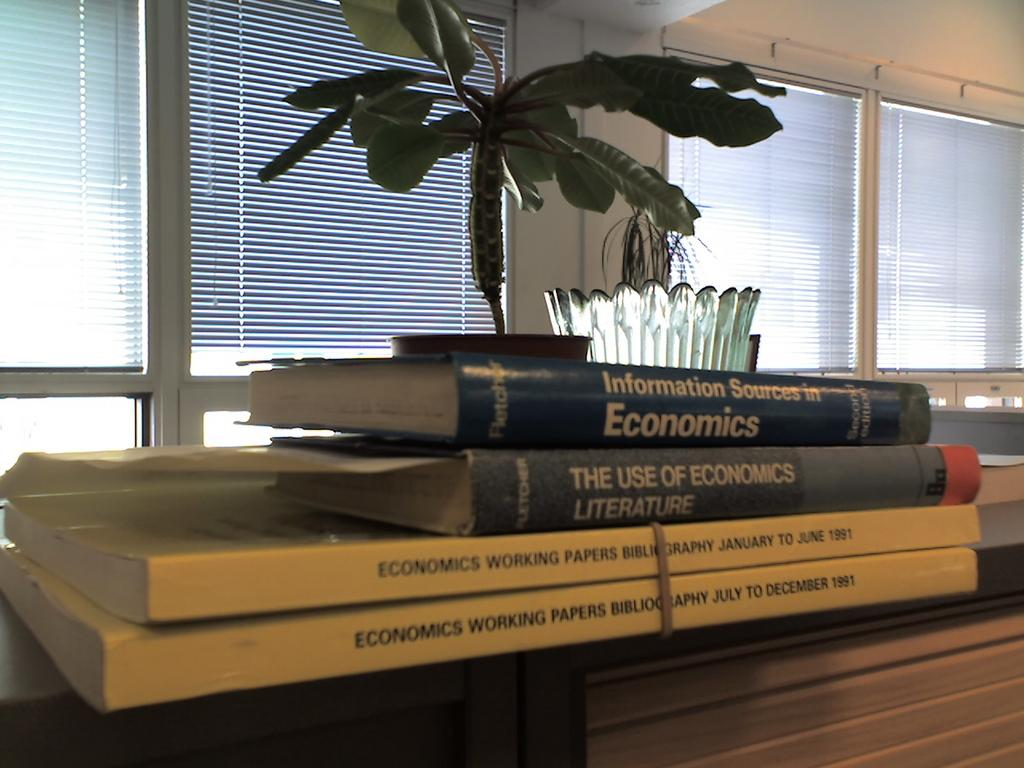What is the main piece of furniture in the image? There is a table in the center of the image. What feature is present on the table? There is a drawer in the image. What items are on the table? There are books, a vase, and a plant on the table. What can be seen in the background of the image? There is a wall, window blinds, and other objects visible in the background of the image. What type of fowl is perched on the vase in the image? There is no fowl present in the image; the vase is empty. 